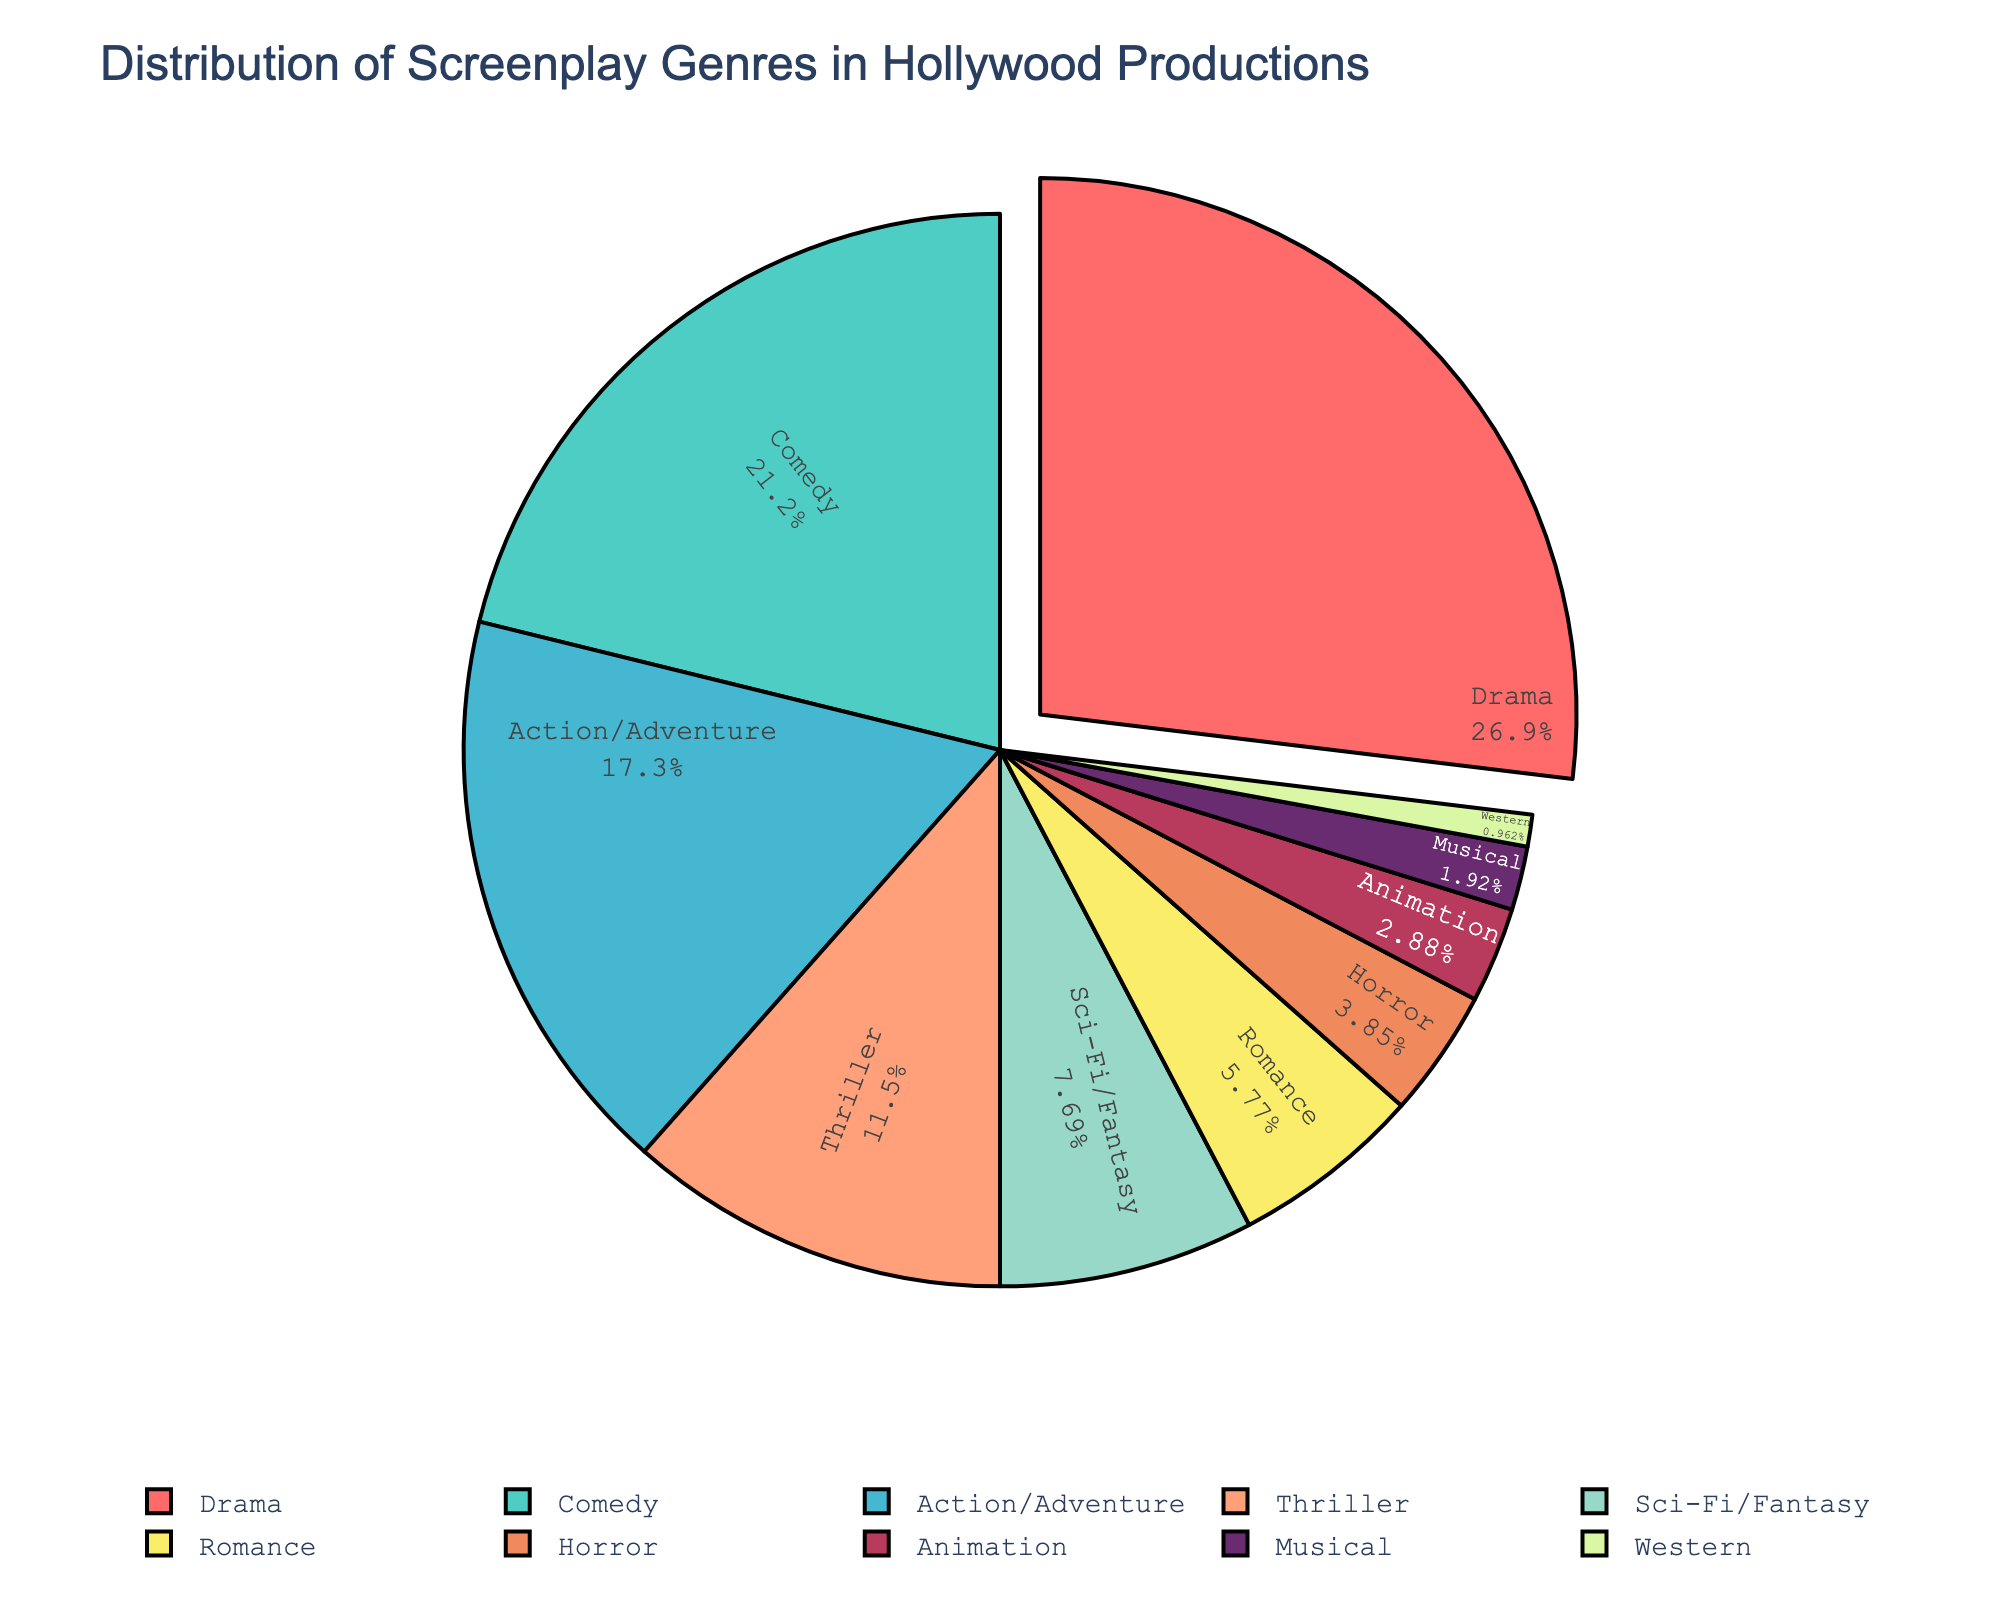Which genre has the highest percentage in Hollywood productions? By looking at the pie chart, you can see that the Drama slice is the largest. Therefore, Drama has the highest percentage.
Answer: Drama What is the total percentage of Action/Adventure and Sci-Fi/Fantasy genres combined? To find the total percentage, you add the percentages of Action/Adventure (18%) and Sci-Fi/Fantasy (8%): 18 + 8 = 26%.
Answer: 26% Which genre occupies a smaller percentage, Musical or Horror? You can compare the sizes of the slices for Musical and Horror in the pie chart. Musical has 2%, and Horror has a larger slice at 4%.
Answer: Musical Are there more Romantic or Comedic screenplays? Comparing the size of the slices, Comedy occupies 22% while Romance occupies 6%. Therefore, there are more Comedic screenplays.
Answer: Comedy How much larger is the percentage of Thriller compared to Western? To find the difference, subtract the percentage of Western (1%) from Thriller (12%): 12 - 1 = 11%.
Answer: 11% Which color represents the genre with the smallest percentage, and what is that genre? By identifying the color of the smallest slice in the pie chart, you can see the Western slice, which is 1% and colored green.
Answer: Western and green What is the combined percentage of Drama, Comedy, and Action/Adventure? Add the percentages of Drama (28%), Comedy (22%), and Action/Adventure (18%): 28 + 22 + 18 = 68%.
Answer: 68% Is the percentage of Animation larger than Romance? The pie chart shows Animation at 3% and Romance at 6%. Therefore, Animation is smaller.
Answer: No What is the second most common genre in Hollywood productions? By looking at the slices, after Drama (28%), Comedy follows with 22%.
Answer: Comedy What is the total percentage of genres that have less than 10% each in Hollywood productions? Summing up percentages of Sci-Fi/Fantasy (8%), Romance (6%), Horror (4%), Animation (3%), Musical (2%), and Western (1%): 8 + 6 + 4 + 3 + 2 + 1 = 24%.
Answer: 24% 